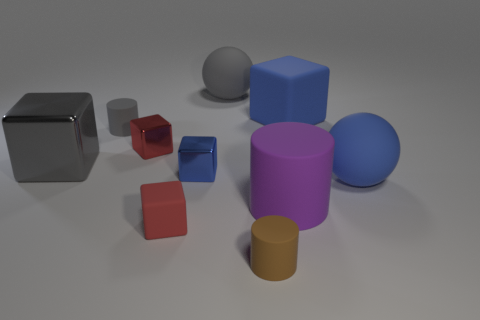The gray thing behind the small rubber cylinder behind the purple object is what shape?
Keep it short and to the point. Sphere. Is the number of purple rubber cylinders that are left of the large gray rubber ball less than the number of large gray rubber objects that are left of the large metal object?
Your response must be concise. No. There is a gray object that is the same shape as the red metal thing; what is its size?
Offer a terse response. Large. Are there any other things that have the same size as the brown rubber cylinder?
Offer a very short reply. Yes. What number of things are either matte things in front of the tiny red rubber block or rubber objects on the right side of the brown cylinder?
Offer a terse response. 4. Is the brown cylinder the same size as the gray metal object?
Give a very brief answer. No. Are there more brown things than spheres?
Your answer should be very brief. No. How many other objects are there of the same color as the big cylinder?
Ensure brevity in your answer.  0. How many objects are big blue matte balls or brown rubber cylinders?
Your response must be concise. 2. Do the red thing that is in front of the purple cylinder and the tiny gray object have the same shape?
Give a very brief answer. No. 